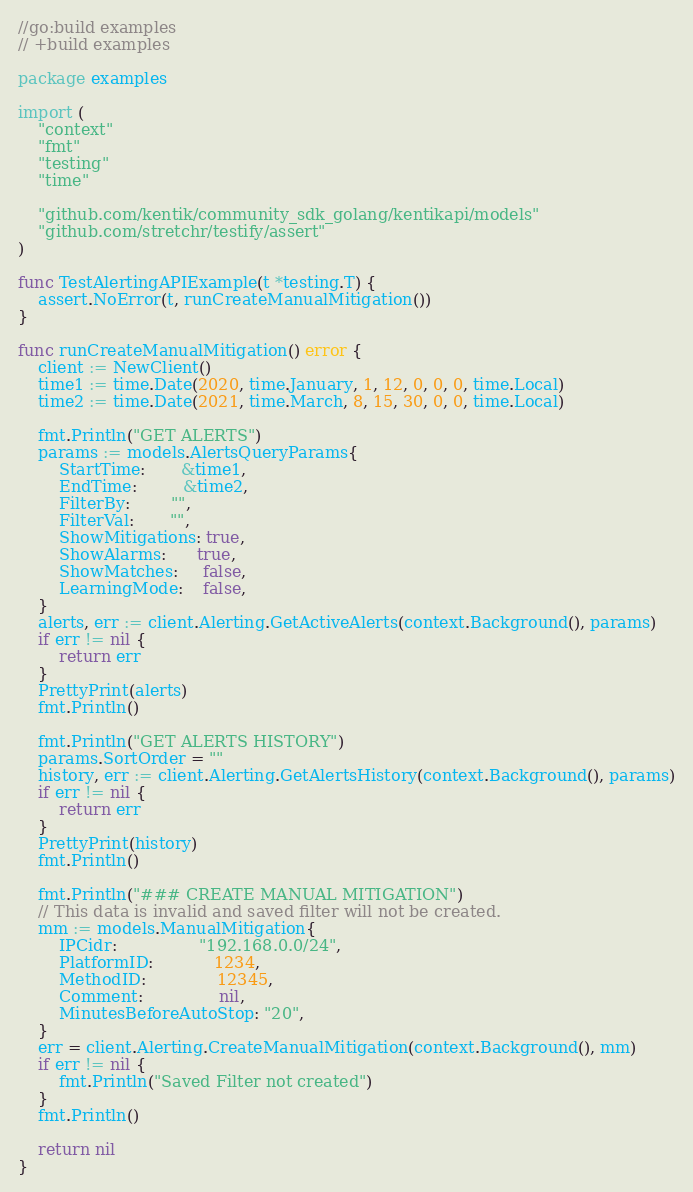Convert code to text. <code><loc_0><loc_0><loc_500><loc_500><_Go_>//go:build examples
// +build examples

package examples

import (
	"context"
	"fmt"
	"testing"
	"time"

	"github.com/kentik/community_sdk_golang/kentikapi/models"
	"github.com/stretchr/testify/assert"
)

func TestAlertingAPIExample(t *testing.T) {
	assert.NoError(t, runCreateManualMitigation())
}

func runCreateManualMitigation() error {
	client := NewClient()
	time1 := time.Date(2020, time.January, 1, 12, 0, 0, 0, time.Local)
	time2 := time.Date(2021, time.March, 8, 15, 30, 0, 0, time.Local)

	fmt.Println("GET ALERTS")
	params := models.AlertsQueryParams{
		StartTime:       &time1,
		EndTime:         &time2,
		FilterBy:        "",
		FilterVal:       "",
		ShowMitigations: true,
		ShowAlarms:      true,
		ShowMatches:     false,
		LearningMode:    false,
	}
	alerts, err := client.Alerting.GetActiveAlerts(context.Background(), params)
	if err != nil {
		return err
	}
	PrettyPrint(alerts)
	fmt.Println()

	fmt.Println("GET ALERTS HISTORY")
	params.SortOrder = ""
	history, err := client.Alerting.GetAlertsHistory(context.Background(), params)
	if err != nil {
		return err
	}
	PrettyPrint(history)
	fmt.Println()

	fmt.Println("### CREATE MANUAL MITIGATION")
	// This data is invalid and saved filter will not be created.
	mm := models.ManualMitigation{
		IPCidr:                "192.168.0.0/24",
		PlatformID:            1234,
		MethodID:              12345,
		Comment:               nil,
		MinutesBeforeAutoStop: "20",
	}
	err = client.Alerting.CreateManualMitigation(context.Background(), mm)
	if err != nil {
		fmt.Println("Saved Filter not created")
	}
	fmt.Println()

	return nil
}
</code> 